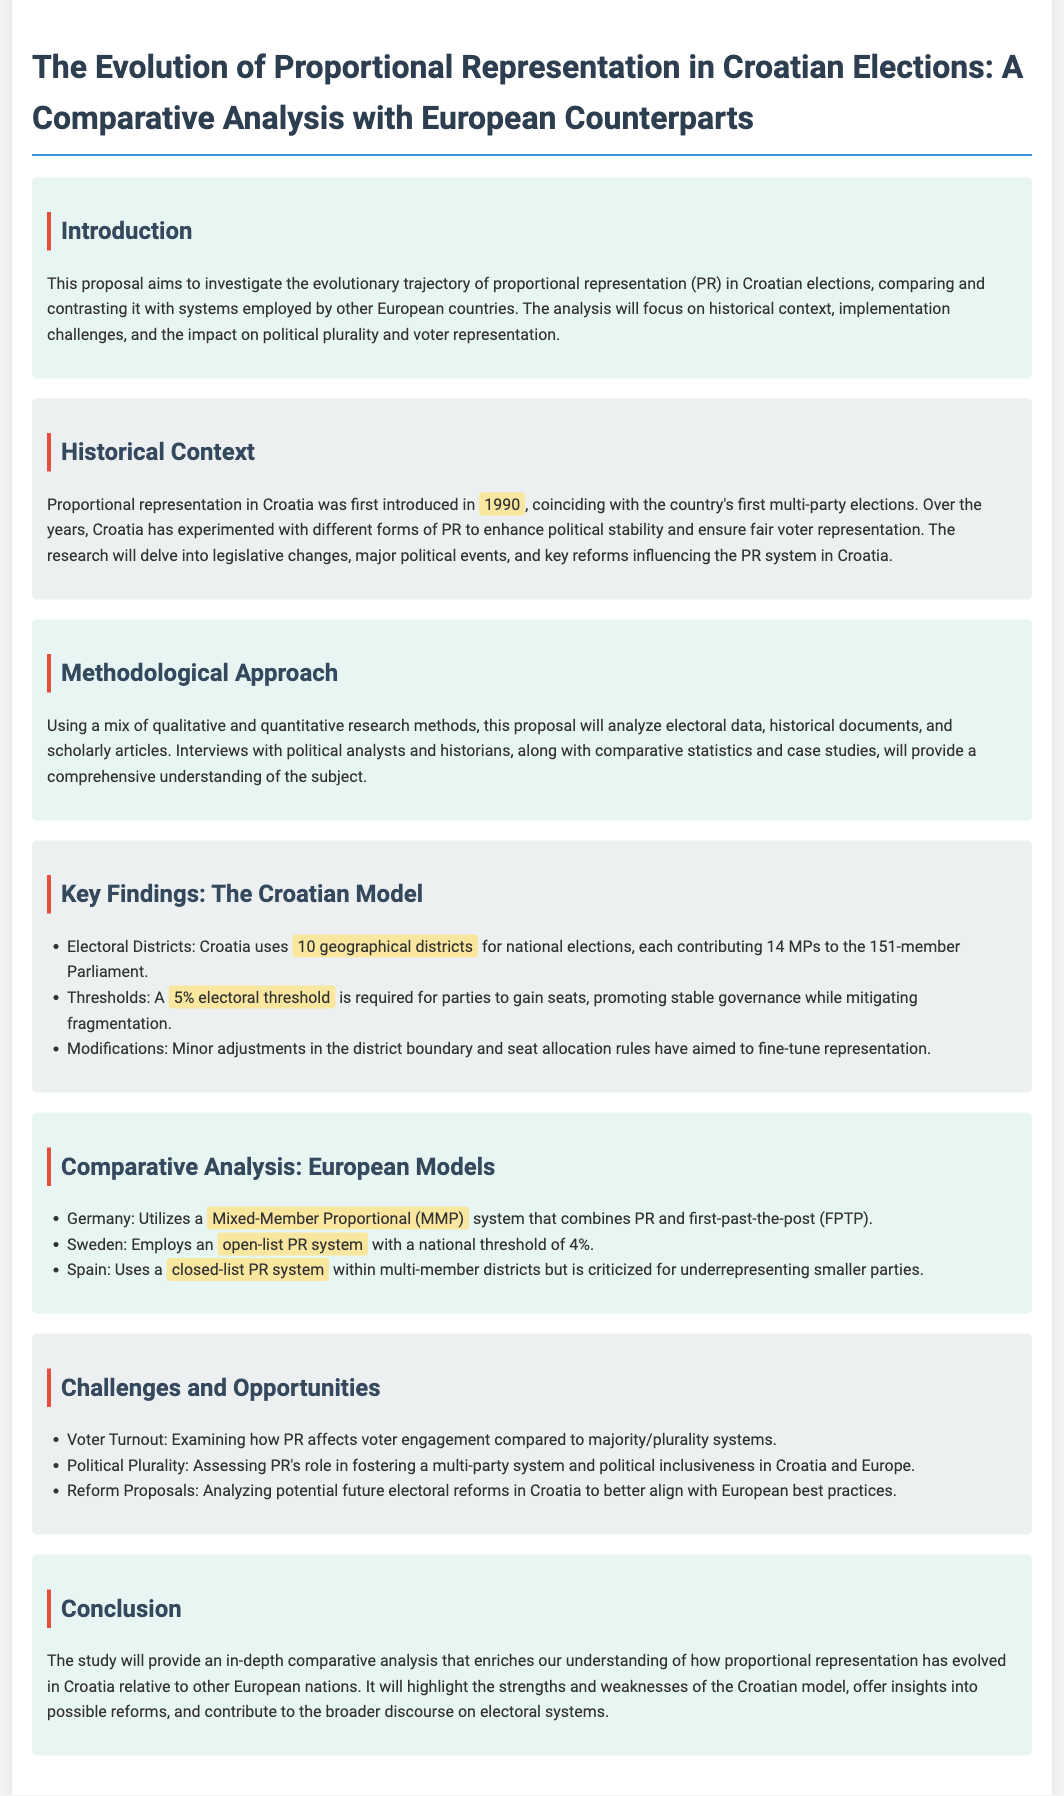What year was proportional representation first introduced in Croatia? The document states that proportional representation in Croatia was first introduced in 1990, coinciding with the country's first multi-party elections.
Answer: 1990 How many geographical districts does Croatia use for national elections? According to the document, Croatia uses 10 geographical districts for national elections.
Answer: 10 What is the required electoral threshold for parties to gain seats in Croatia? The proposal mentions that a 5% electoral threshold is required for parties to gain seats.
Answer: 5% Which electoral system does Germany utilize? The document identifies that Germany utilizes a Mixed-Member Proportional (MMP) system.
Answer: Mixed-Member Proportional (MMP) What aspect of voter behavior is examined in relation to proportional representation? The proposal discusses the examination of how PR affects voter engagement compared to majority/plurality systems.
Answer: Voter engagement What is the main objective of the study? The main objective is to provide an in-depth comparative analysis of proportional representation in Croatia relative to other European nations.
Answer: Comparative analysis How many members are in the Croatian Parliament? The document specifies that there are 151 members in the Croatian Parliament.
Answer: 151 What type of PR system does Sweden employ? The proposal states that Sweden employs an open-list PR system.
Answer: Open-list PR system 